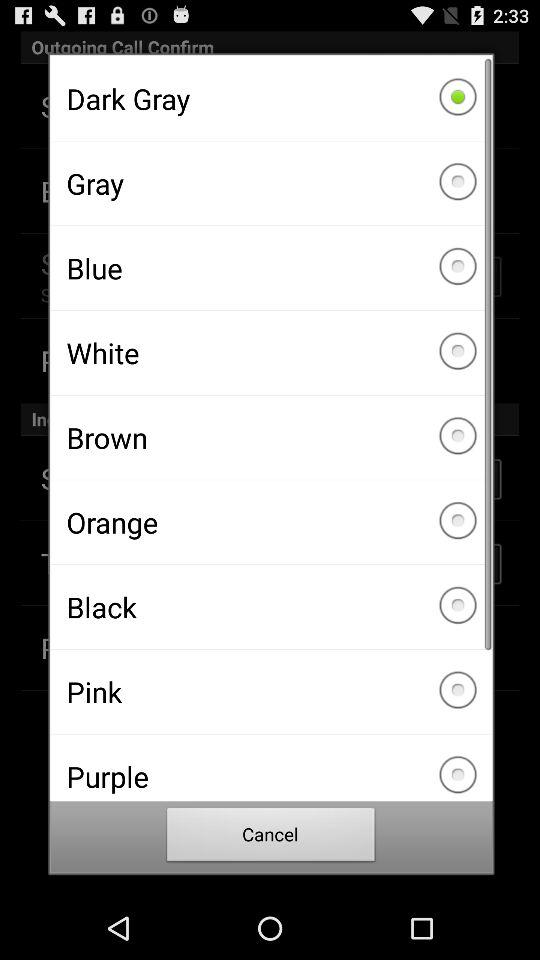How many color options are there?
Answer the question using a single word or phrase. 9 